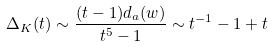<formula> <loc_0><loc_0><loc_500><loc_500>\Delta _ { K } ( t ) \sim \frac { ( t - 1 ) d _ { a } ( w ) } { t ^ { 5 } - 1 } \sim t ^ { - 1 } - 1 + t</formula> 